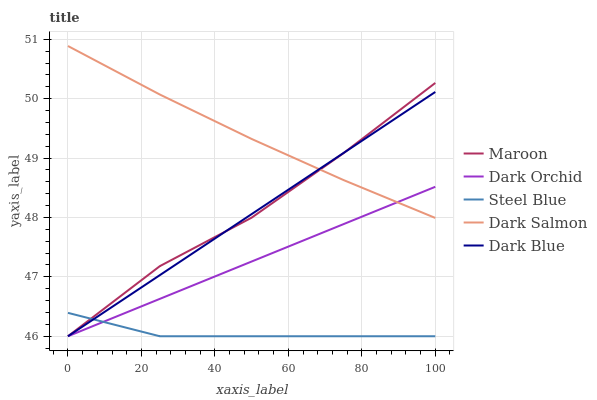Does Steel Blue have the minimum area under the curve?
Answer yes or no. Yes. Does Dark Salmon have the maximum area under the curve?
Answer yes or no. Yes. Does Dark Orchid have the minimum area under the curve?
Answer yes or no. No. Does Dark Orchid have the maximum area under the curve?
Answer yes or no. No. Is Dark Blue the smoothest?
Answer yes or no. Yes. Is Maroon the roughest?
Answer yes or no. Yes. Is Dark Salmon the smoothest?
Answer yes or no. No. Is Dark Salmon the roughest?
Answer yes or no. No. Does Dark Blue have the lowest value?
Answer yes or no. Yes. Does Dark Salmon have the lowest value?
Answer yes or no. No. Does Dark Salmon have the highest value?
Answer yes or no. Yes. Does Dark Orchid have the highest value?
Answer yes or no. No. Is Steel Blue less than Dark Salmon?
Answer yes or no. Yes. Is Dark Salmon greater than Steel Blue?
Answer yes or no. Yes. Does Steel Blue intersect Dark Blue?
Answer yes or no. Yes. Is Steel Blue less than Dark Blue?
Answer yes or no. No. Is Steel Blue greater than Dark Blue?
Answer yes or no. No. Does Steel Blue intersect Dark Salmon?
Answer yes or no. No. 